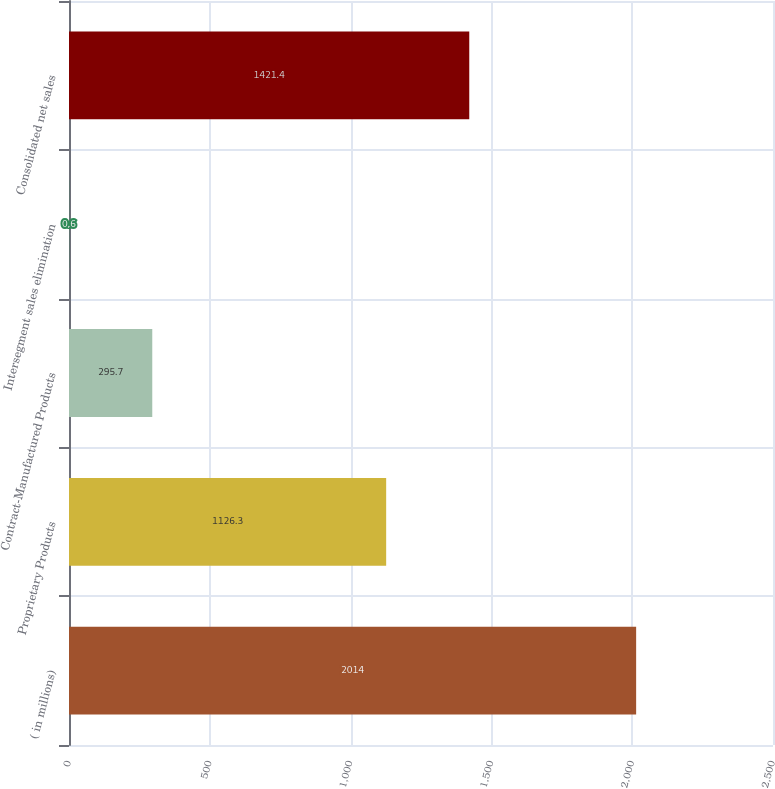Convert chart. <chart><loc_0><loc_0><loc_500><loc_500><bar_chart><fcel>( in millions)<fcel>Proprietary Products<fcel>Contract-Manufactured Products<fcel>Intersegment sales elimination<fcel>Consolidated net sales<nl><fcel>2014<fcel>1126.3<fcel>295.7<fcel>0.6<fcel>1421.4<nl></chart> 